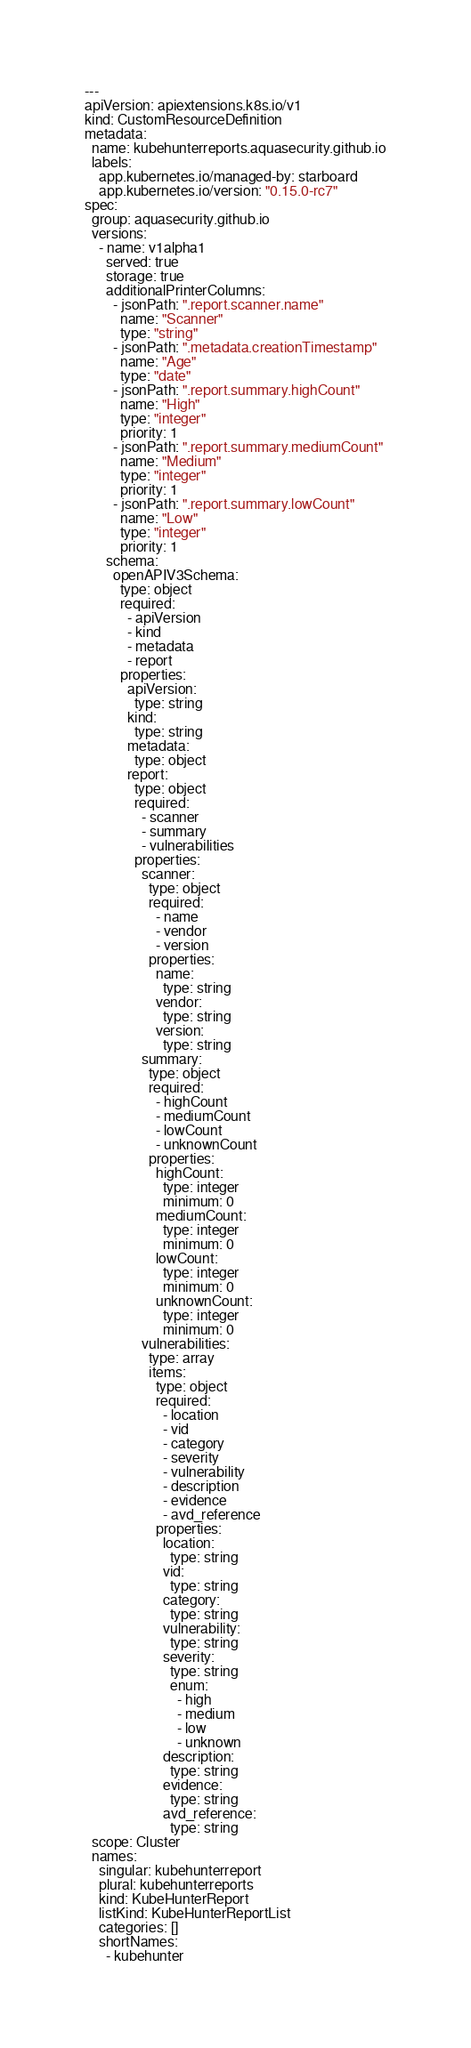Convert code to text. <code><loc_0><loc_0><loc_500><loc_500><_YAML_>---
apiVersion: apiextensions.k8s.io/v1
kind: CustomResourceDefinition
metadata:
  name: kubehunterreports.aquasecurity.github.io
  labels:
    app.kubernetes.io/managed-by: starboard
    app.kubernetes.io/version: "0.15.0-rc7"
spec:
  group: aquasecurity.github.io
  versions:
    - name: v1alpha1
      served: true
      storage: true
      additionalPrinterColumns:
        - jsonPath: ".report.scanner.name"
          name: "Scanner"
          type: "string"
        - jsonPath: ".metadata.creationTimestamp"
          name: "Age"
          type: "date"
        - jsonPath: ".report.summary.highCount"
          name: "High"
          type: "integer"
          priority: 1
        - jsonPath: ".report.summary.mediumCount"
          name: "Medium"
          type: "integer"
          priority: 1
        - jsonPath: ".report.summary.lowCount"
          name: "Low"
          type: "integer"
          priority: 1
      schema:
        openAPIV3Schema:
          type: object
          required:
            - apiVersion
            - kind
            - metadata
            - report
          properties:
            apiVersion:
              type: string
            kind:
              type: string
            metadata:
              type: object
            report:
              type: object
              required:
                - scanner
                - summary
                - vulnerabilities
              properties:
                scanner:
                  type: object
                  required:
                    - name
                    - vendor
                    - version
                  properties:
                    name:
                      type: string
                    vendor:
                      type: string
                    version:
                      type: string
                summary:
                  type: object
                  required:
                    - highCount
                    - mediumCount
                    - lowCount
                    - unknownCount
                  properties:
                    highCount:
                      type: integer
                      minimum: 0
                    mediumCount:
                      type: integer
                      minimum: 0
                    lowCount:
                      type: integer
                      minimum: 0
                    unknownCount:
                      type: integer
                      minimum: 0
                vulnerabilities:
                  type: array
                  items:
                    type: object
                    required:
                      - location
                      - vid
                      - category
                      - severity
                      - vulnerability
                      - description
                      - evidence
                      - avd_reference
                    properties:
                      location:
                        type: string
                      vid:
                        type: string
                      category:
                        type: string
                      vulnerability:
                        type: string
                      severity:
                        type: string
                        enum:
                          - high
                          - medium
                          - low
                          - unknown
                      description:
                        type: string
                      evidence:
                        type: string
                      avd_reference:
                        type: string
  scope: Cluster
  names:
    singular: kubehunterreport
    plural: kubehunterreports
    kind: KubeHunterReport
    listKind: KubeHunterReportList
    categories: []
    shortNames:
      - kubehunter
</code> 